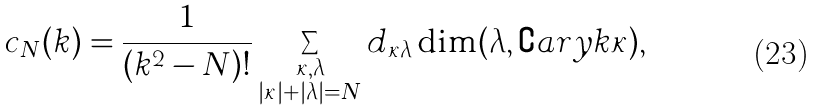Convert formula to latex. <formula><loc_0><loc_0><loc_500><loc_500>c _ { N } ( k ) = \frac { 1 } { ( k ^ { 2 } - N ) ! } \sum _ { \substack { \kappa , \lambda \\ | \kappa | + | \lambda | = N } } d _ { \kappa \lambda } \dim ( \lambda , \complement a r y { k } { \kappa } ) ,</formula> 